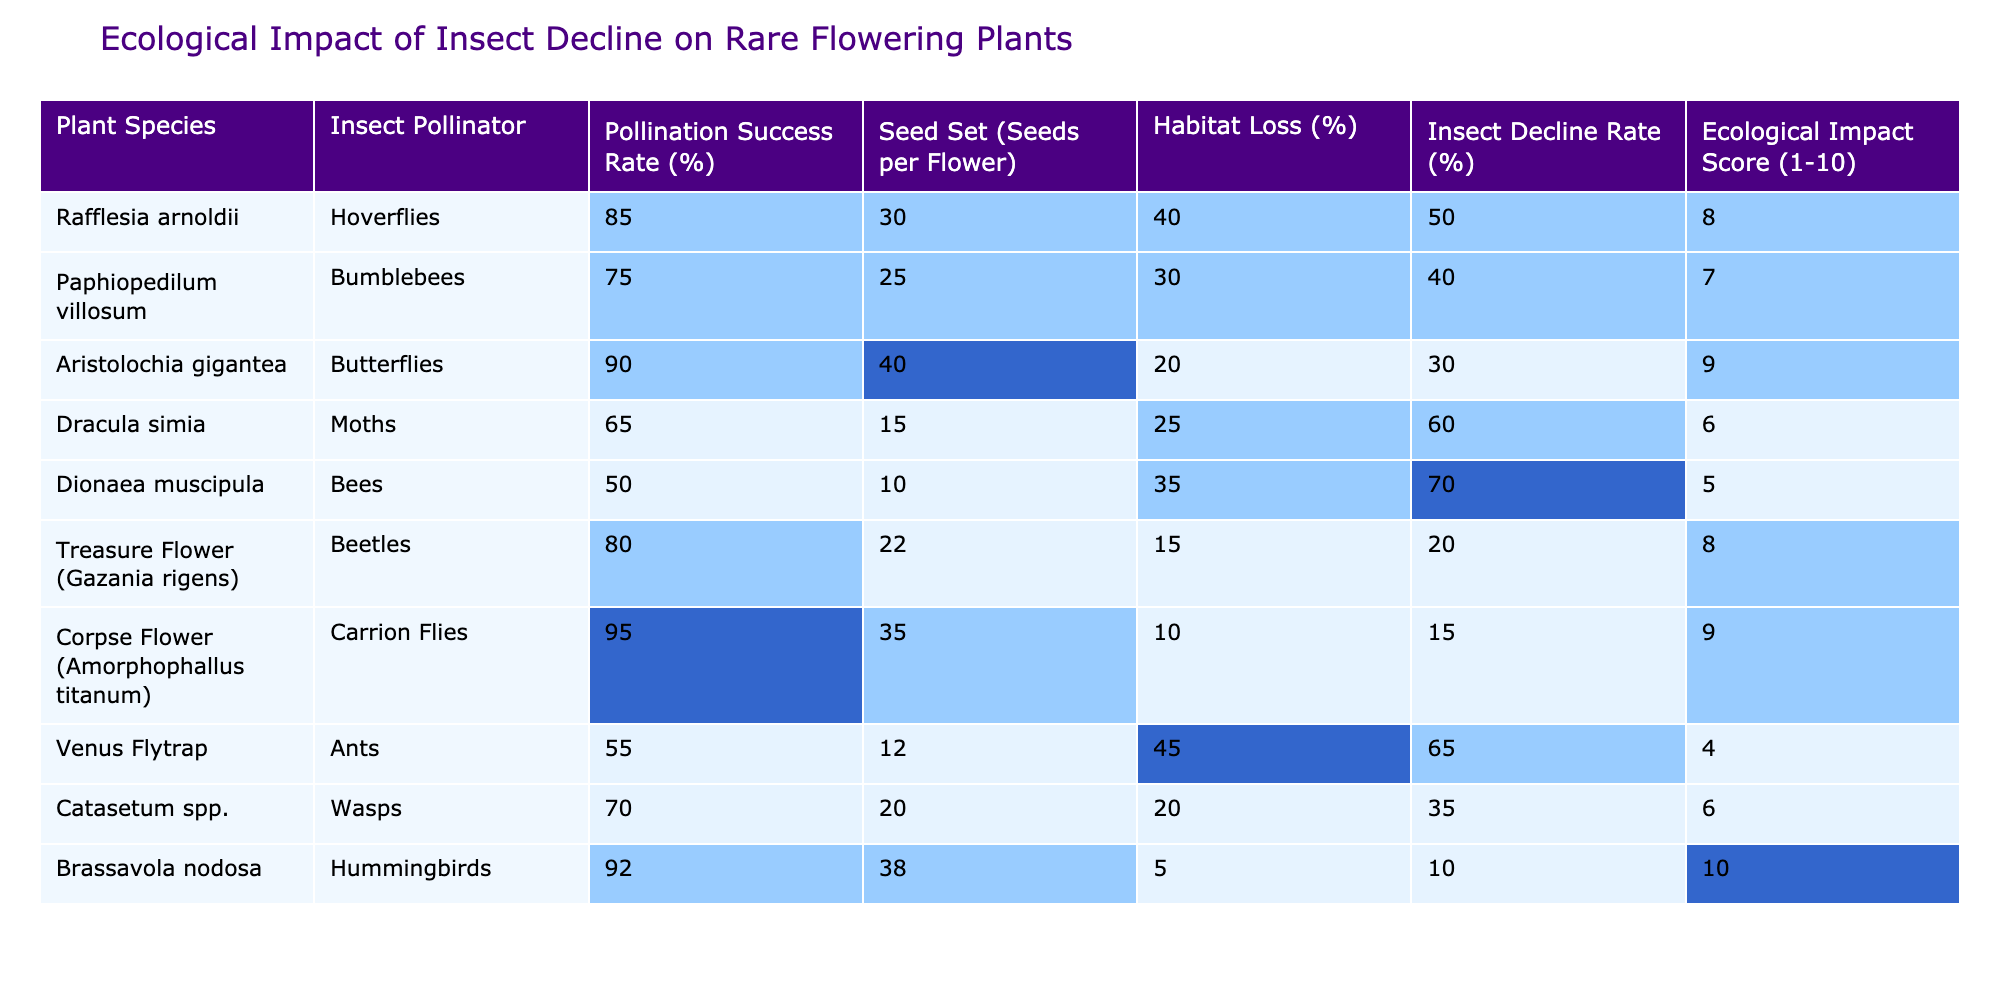What is the pollination success rate of Brassavola nodosa? The table shows a pollination success rate of 92% for Brassavola nodosa.
Answer: 92% Which plant species has the highest ecological impact score? By comparing the ecological impact scores, Brassavola nodosa has the highest score of 10.
Answer: Brassavola nodosa What is the average seed set for plants that have an insect decline rate over 50%? The plants with insect decline rates over 50% are Dionaea muscipula, Dracula simia, and Rafflesia arnoldii with seed sets of 10, 15, and 30 respectively. The average is (10 + 15 + 30) / 3 = 55 / 3 = 18.33, rounded to 18.
Answer: 18 Is there a correlation between habitat loss and seed set in the table? From the data, we can see that habitat loss and seed set do not have a clear positive or negative correlation. For example, Rafflesia arnoldii has 40% habitat loss and a seed set of 30, while Brassavola nodosa has 5% habitat loss with a seed set of 38.
Answer: No How many types of pollinators are represented in this table? The table lists 10 different plant species, each with a unique insect pollinator, totaling 10 types of pollinators: Hoverflies, Bumblebees, Butterflies, Moths, Bees, Beetles, Carrion Flies, Ants, Wasps, and Hummingbirds.
Answer: 10 What is the difference in pollination success rate between Aristolochia gigantea and Venus Flytrap? Aristolochia gigantea has a pollination success rate of 90%, while Venus Flytrap has 55%. Thus, the difference is 90 - 55 = 35%.
Answer: 35% Which plant species with the highest seed set has the least habitat loss? Brassavola nodosa has the highest seed set of 38 and the least habitat loss at 5%.
Answer: Brassavola nodosa How does the insect decline rate affect the ecological impact score, specifically for plants with a decline rate above 50%? Among the plants with insect decline rates above 50%, the ecological impact scores are 6 for Dracula simia and 5 for Dionaea muscipula, while Rafflesia arnoldii has 8. As the decline rate increases from 50% to 70%, the score decreases from 8 to 5, indicating a negative correlation.
Answer: Negative correlation Which plant species shows the lowest seed set? The lowest seed set is noted for Dionaea muscipula, which has a seed set of 10.
Answer: Dionaea muscipula What can be inferred about the relationship between the pollination success rate and the ecological impact score for the plants studied? Analyzing the data, there appears to be a positive trend; higher pollination success rates generally correspond with higher ecological impact scores. For instance, a pollination success rate of 95% for Corpse Flower corresponds with an ecological impact score of 9.
Answer: Positive trend 